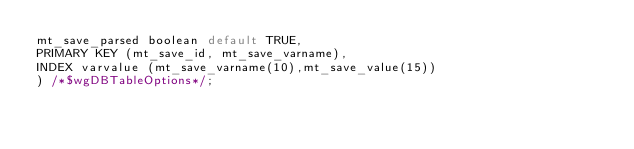Convert code to text. <code><loc_0><loc_0><loc_500><loc_500><_SQL_>mt_save_parsed boolean default TRUE,
PRIMARY KEY (mt_save_id, mt_save_varname),
INDEX varvalue (mt_save_varname(10),mt_save_value(15))
) /*$wgDBTableOptions*/;

</code> 